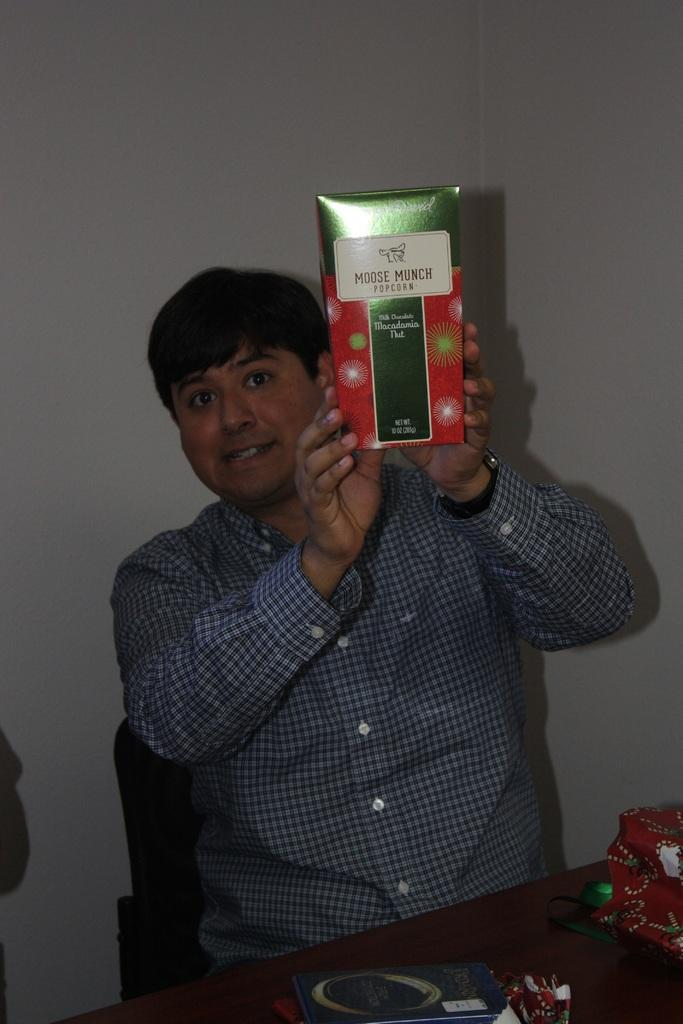<image>
Provide a brief description of the given image. A man holds up a box of moose munch popcorn. 